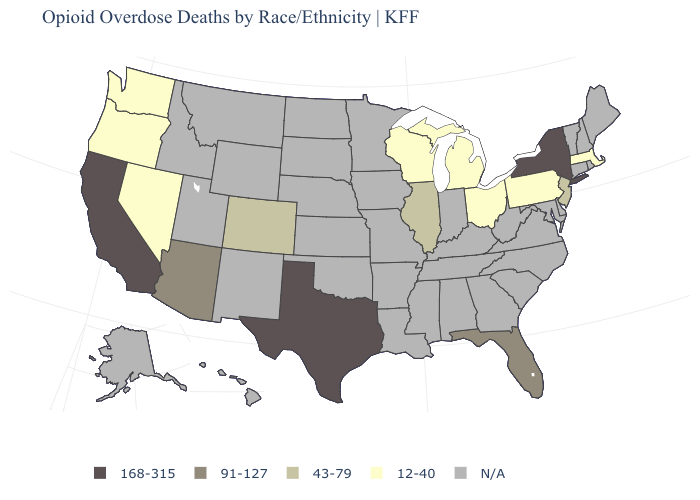Which states hav the highest value in the West?
Concise answer only. California. What is the value of Wisconsin?
Answer briefly. 12-40. Which states have the highest value in the USA?
Keep it brief. California, New York, Texas. Name the states that have a value in the range 12-40?
Short answer required. Massachusetts, Michigan, Nevada, Ohio, Oregon, Pennsylvania, Washington, Wisconsin. Does Oregon have the lowest value in the West?
Short answer required. Yes. Name the states that have a value in the range 91-127?
Be succinct. Arizona, Florida. Name the states that have a value in the range 168-315?
Short answer required. California, New York, Texas. What is the highest value in states that border Oklahoma?
Answer briefly. 168-315. What is the value of Alaska?
Keep it brief. N/A. What is the lowest value in the USA?
Write a very short answer. 12-40. Does Texas have the lowest value in the South?
Short answer required. No. Which states have the lowest value in the South?
Write a very short answer. Florida. What is the value of Texas?
Be succinct. 168-315. Name the states that have a value in the range 12-40?
Give a very brief answer. Massachusetts, Michigan, Nevada, Ohio, Oregon, Pennsylvania, Washington, Wisconsin. 